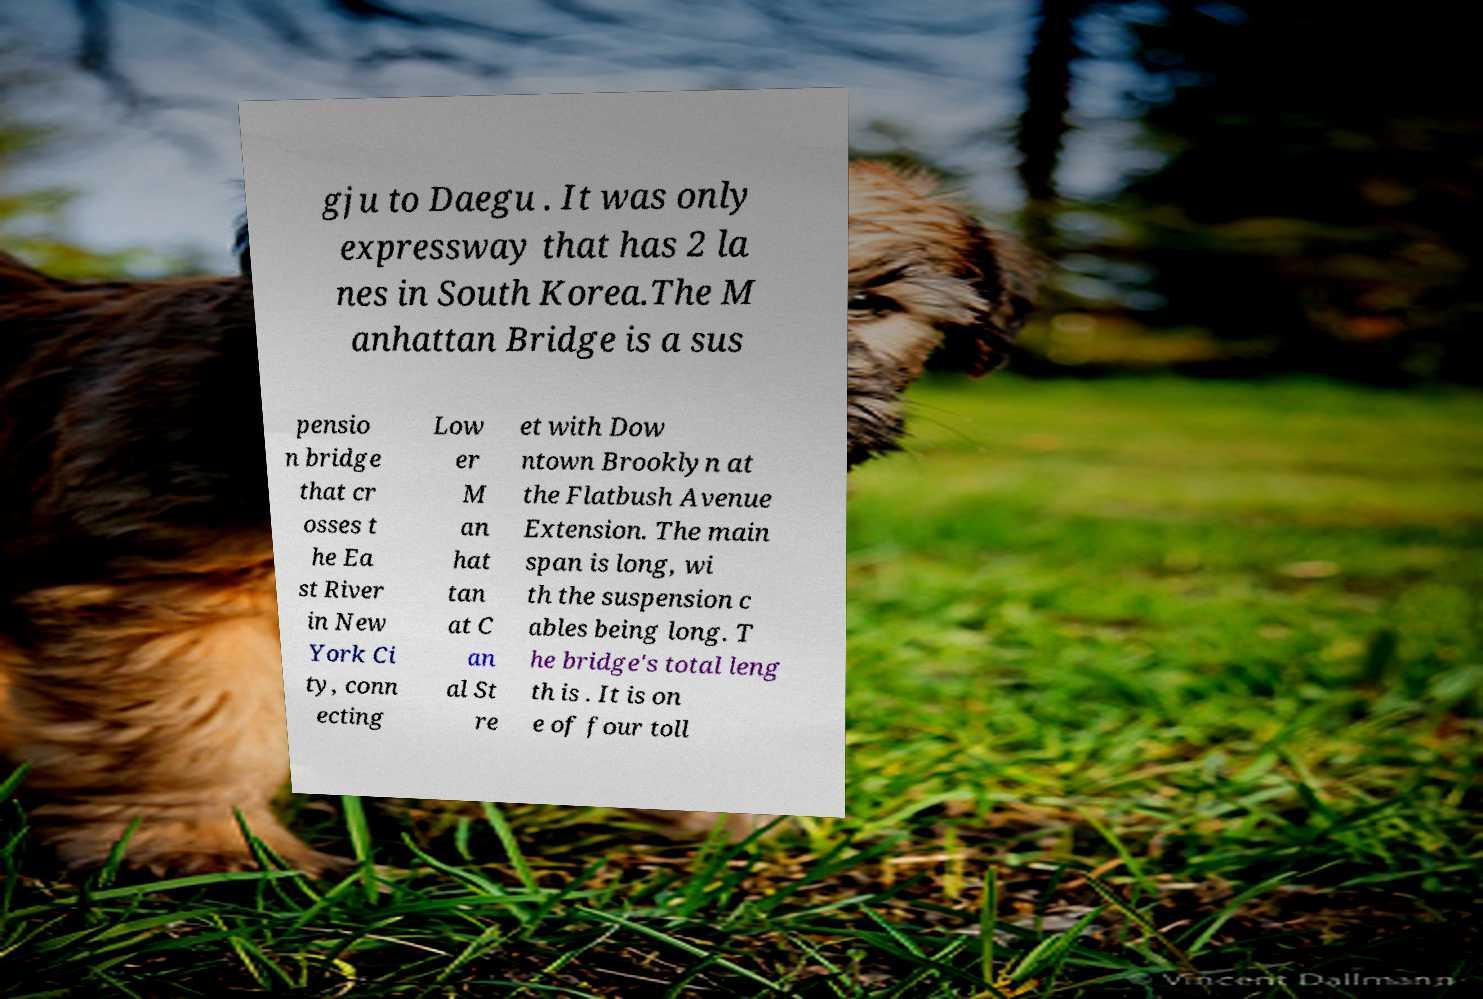Can you read and provide the text displayed in the image?This photo seems to have some interesting text. Can you extract and type it out for me? gju to Daegu . It was only expressway that has 2 la nes in South Korea.The M anhattan Bridge is a sus pensio n bridge that cr osses t he Ea st River in New York Ci ty, conn ecting Low er M an hat tan at C an al St re et with Dow ntown Brooklyn at the Flatbush Avenue Extension. The main span is long, wi th the suspension c ables being long. T he bridge's total leng th is . It is on e of four toll 